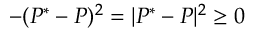<formula> <loc_0><loc_0><loc_500><loc_500>- ( P ^ { * } - P ) ^ { 2 } = | P ^ { * } - P | ^ { 2 } \geq 0</formula> 